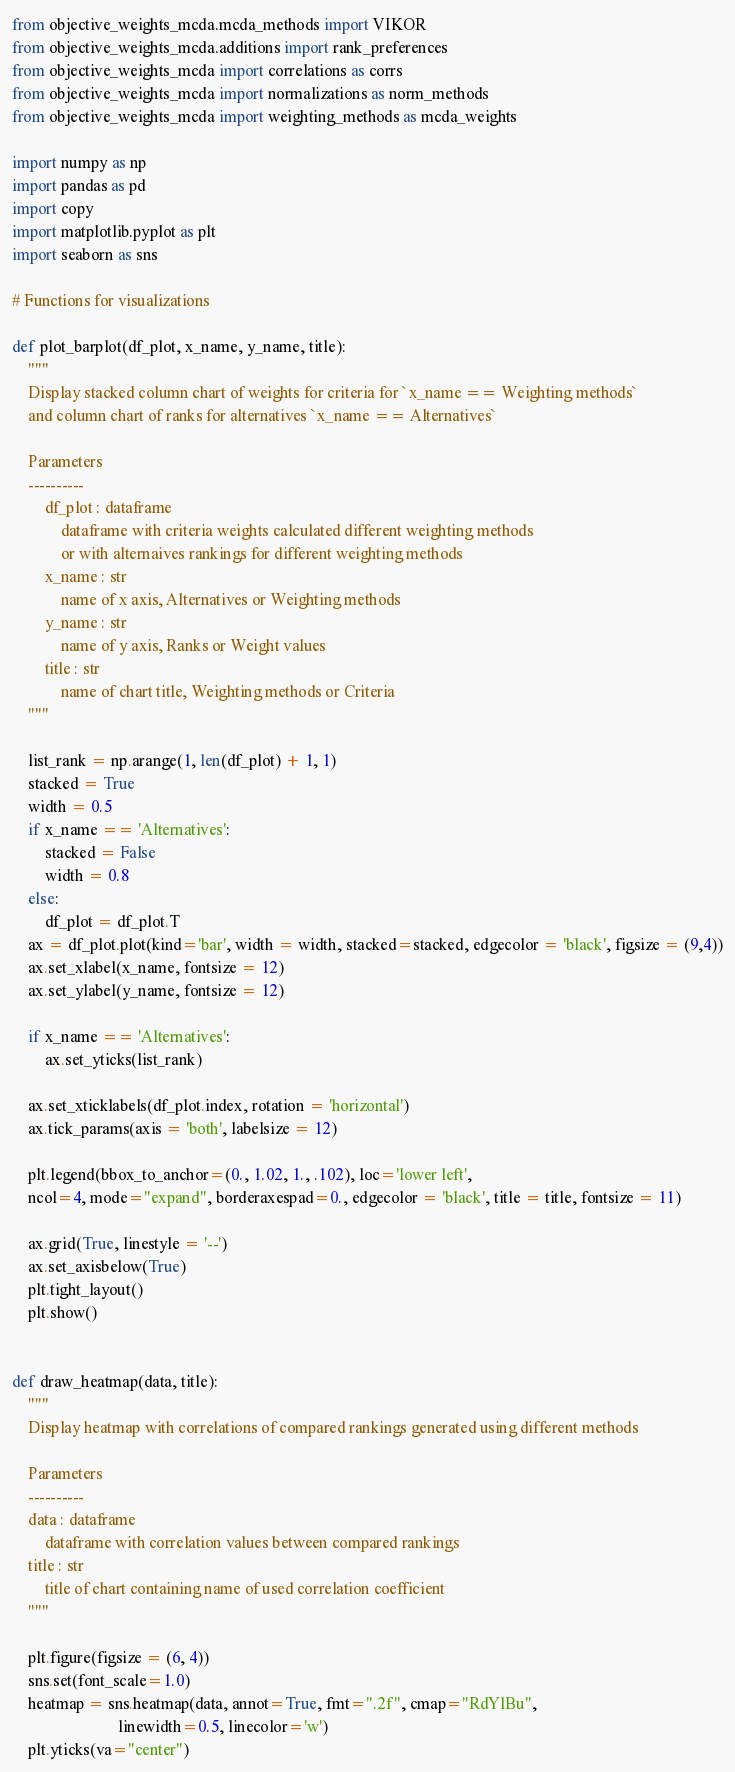Convert code to text. <code><loc_0><loc_0><loc_500><loc_500><_Python_>from objective_weights_mcda.mcda_methods import VIKOR
from objective_weights_mcda.additions import rank_preferences
from objective_weights_mcda import correlations as corrs
from objective_weights_mcda import normalizations as norm_methods
from objective_weights_mcda import weighting_methods as mcda_weights

import numpy as np
import pandas as pd
import copy
import matplotlib.pyplot as plt
import seaborn as sns

# Functions for visualizations

def plot_barplot(df_plot, x_name, y_name, title):
    """
    Display stacked column chart of weights for criteria for `x_name == Weighting methods`
    and column chart of ranks for alternatives `x_name == Alternatives`

    Parameters
    ----------
        df_plot : dataframe
            dataframe with criteria weights calculated different weighting methods
            or with alternaives rankings for different weighting methods
        x_name : str
            name of x axis, Alternatives or Weighting methods
        y_name : str
            name of y axis, Ranks or Weight values
        title : str
            name of chart title, Weighting methods or Criteria
    """
    
    list_rank = np.arange(1, len(df_plot) + 1, 1)
    stacked = True
    width = 0.5
    if x_name == 'Alternatives':
        stacked = False
        width = 0.8
    else:
        df_plot = df_plot.T
    ax = df_plot.plot(kind='bar', width = width, stacked=stacked, edgecolor = 'black', figsize = (9,4))
    ax.set_xlabel(x_name, fontsize = 12)
    ax.set_ylabel(y_name, fontsize = 12)

    if x_name == 'Alternatives':
        ax.set_yticks(list_rank)

    ax.set_xticklabels(df_plot.index, rotation = 'horizontal')
    ax.tick_params(axis = 'both', labelsize = 12)

    plt.legend(bbox_to_anchor=(0., 1.02, 1., .102), loc='lower left',
    ncol=4, mode="expand", borderaxespad=0., edgecolor = 'black', title = title, fontsize = 11)

    ax.grid(True, linestyle = '--')
    ax.set_axisbelow(True)
    plt.tight_layout()
    plt.show()


def draw_heatmap(data, title):
    """
    Display heatmap with correlations of compared rankings generated using different methods

    Parameters
    ----------
    data : dataframe
        dataframe with correlation values between compared rankings
    title : str
        title of chart containing name of used correlation coefficient
    """

    plt.figure(figsize = (6, 4))
    sns.set(font_scale=1.0)
    heatmap = sns.heatmap(data, annot=True, fmt=".2f", cmap="RdYlBu",
                          linewidth=0.5, linecolor='w')
    plt.yticks(va="center")</code> 